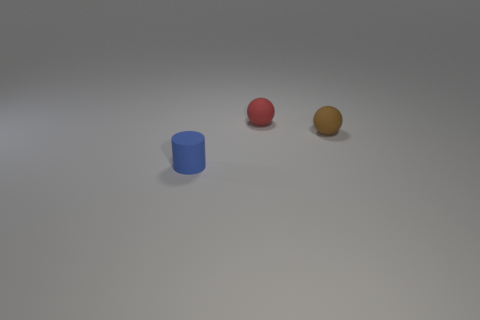Add 2 small red rubber spheres. How many objects exist? 5 Subtract all spheres. How many objects are left? 1 Add 3 small matte balls. How many small matte balls exist? 5 Subtract 1 blue cylinders. How many objects are left? 2 Subtract all tiny red matte things. Subtract all small yellow rubber objects. How many objects are left? 2 Add 1 small red matte spheres. How many small red matte spheres are left? 2 